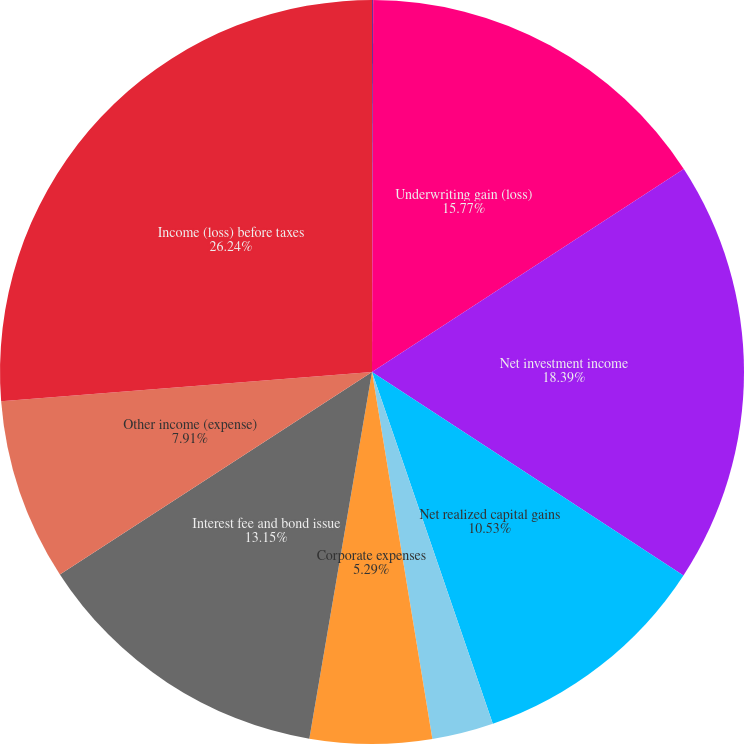Convert chart. <chart><loc_0><loc_0><loc_500><loc_500><pie_chart><fcel>(Dollars in thousands)<fcel>Underwriting gain (loss)<fcel>Net investment income<fcel>Net realized capital gains<fcel>Net derivative expense<fcel>Corporate expenses<fcel>Interest fee and bond issue<fcel>Other income (expense)<fcel>Income (loss) before taxes<nl><fcel>0.05%<fcel>15.77%<fcel>18.39%<fcel>10.53%<fcel>2.67%<fcel>5.29%<fcel>13.15%<fcel>7.91%<fcel>26.25%<nl></chart> 